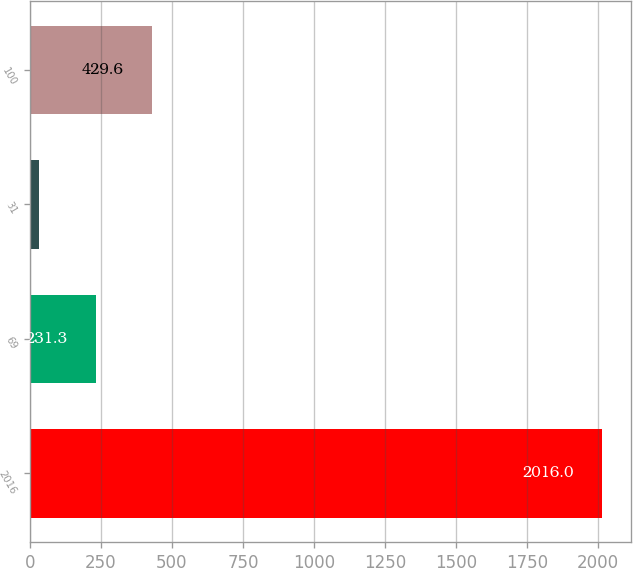Convert chart. <chart><loc_0><loc_0><loc_500><loc_500><bar_chart><fcel>2016<fcel>69<fcel>31<fcel>100<nl><fcel>2016<fcel>231.3<fcel>33<fcel>429.6<nl></chart> 